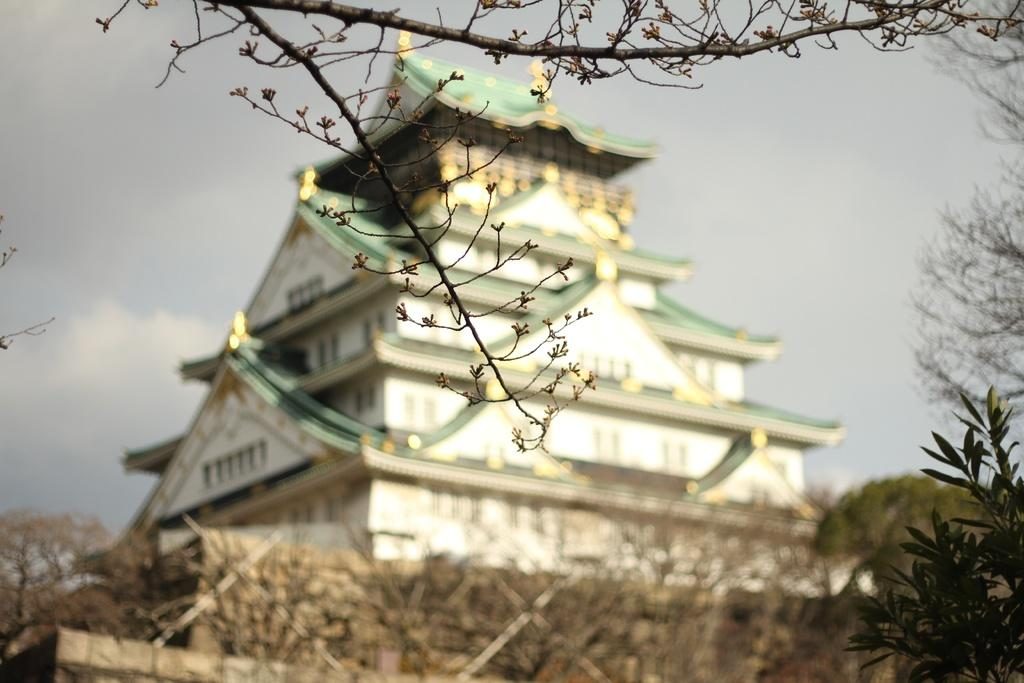What type of structure can be seen in the image? There is a building in the image. What other natural elements are present in the image? There are trees and branches visible in the image. What is visible in the background of the image? The sky is visible in the background of the image. What can be observed in the sky? Clouds are present in the sky. What type of prose can be seen in the image? There is no prose present in the image. Prose is a form of written or spoken language, and the image only contains visual elements. 